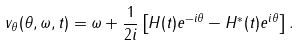<formula> <loc_0><loc_0><loc_500><loc_500>v _ { \theta } ( \theta , \omega , t ) = \omega + \frac { 1 } { 2 i } \left [ H ( t ) e ^ { - i \theta } - H ^ { * } ( t ) e ^ { i \theta } \right ] .</formula> 